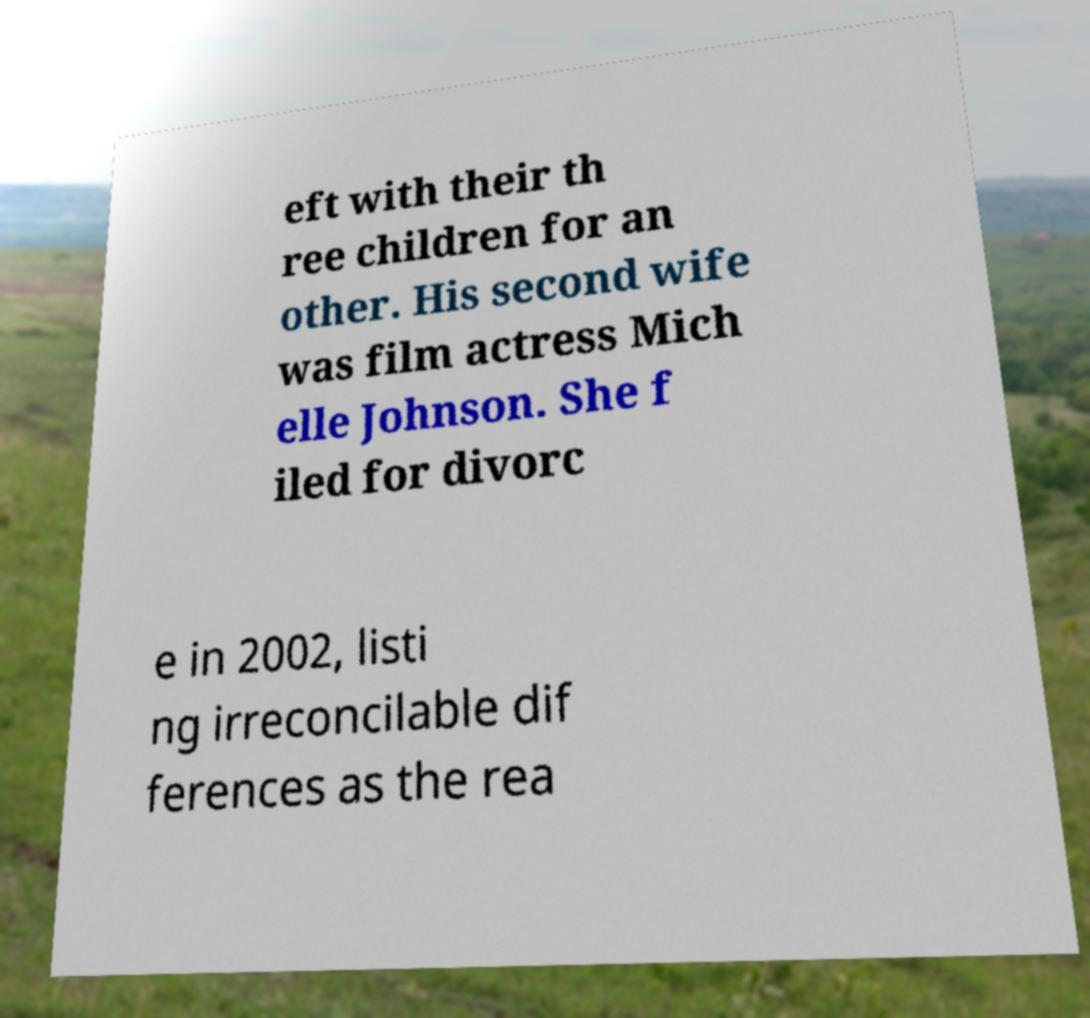I need the written content from this picture converted into text. Can you do that? eft with their th ree children for an other. His second wife was film actress Mich elle Johnson. She f iled for divorc e in 2002, listi ng irreconcilable dif ferences as the rea 